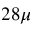<formula> <loc_0><loc_0><loc_500><loc_500>2 8 \mu</formula> 